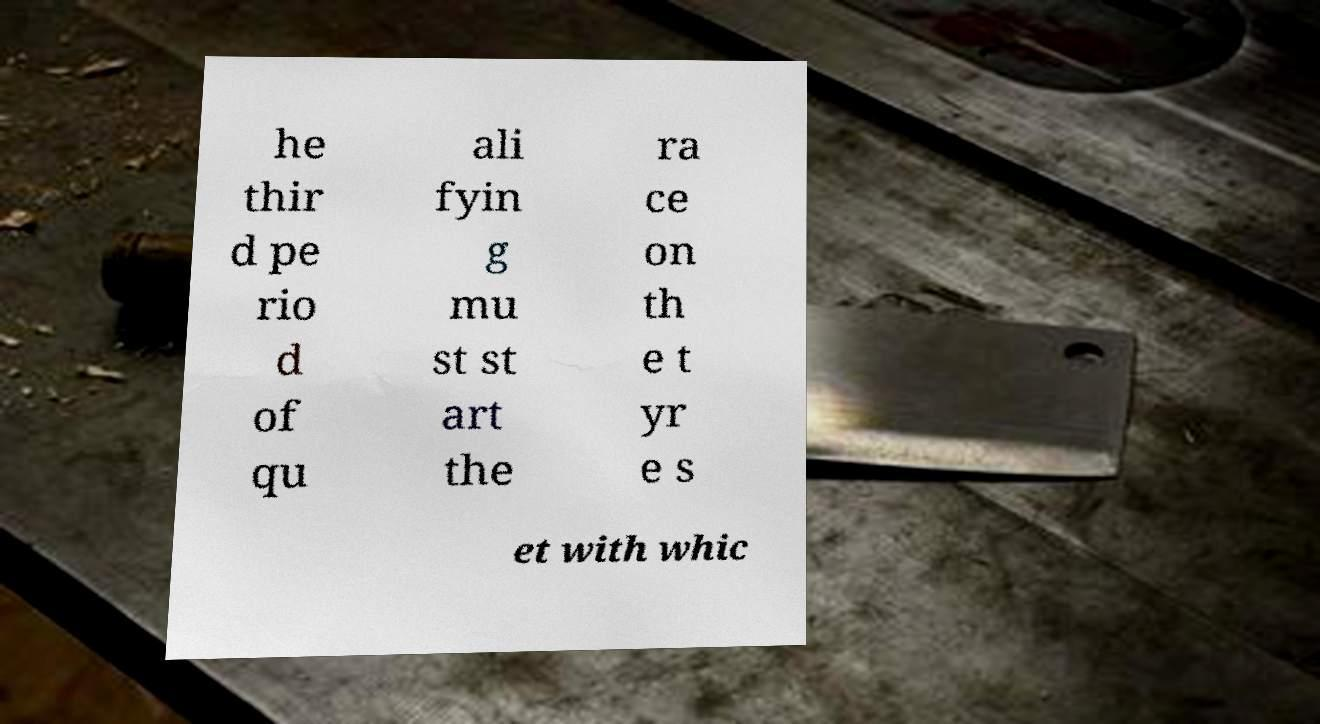Could you assist in decoding the text presented in this image and type it out clearly? he thir d pe rio d of qu ali fyin g mu st st art the ra ce on th e t yr e s et with whic 